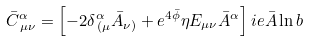Convert formula to latex. <formula><loc_0><loc_0><loc_500><loc_500>\bar { C } ^ { \alpha } _ { \, \mu \nu } = \left [ - 2 \delta ^ { \alpha } _ { \, ( \mu } \bar { A } _ { \nu ) } + e ^ { 4 \bar { \phi } } \eta E _ { \mu \nu } \bar { A } ^ { \alpha } \right ] \L i e { \bar { A } } \ln b</formula> 